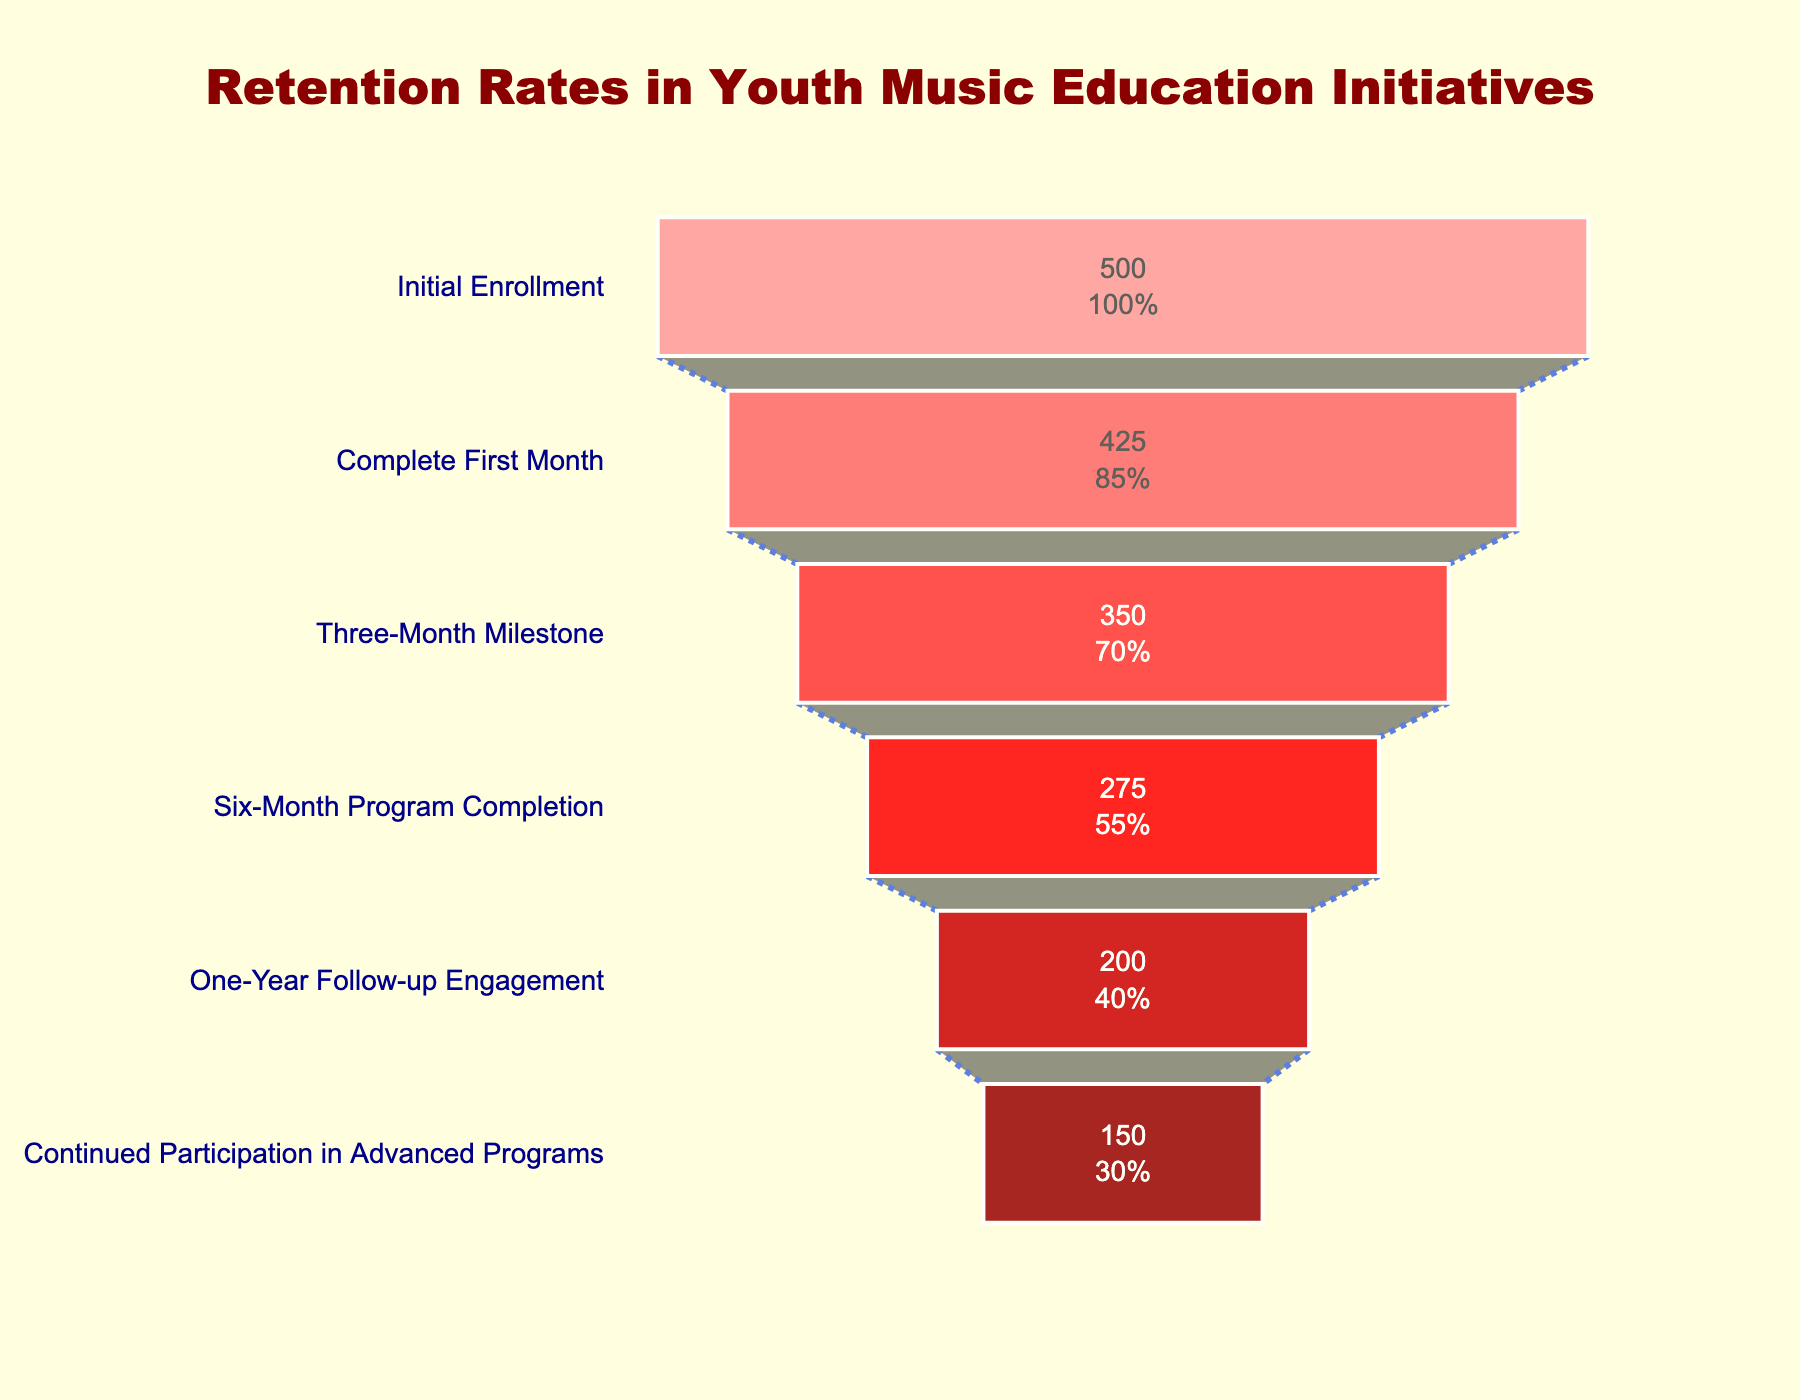How many participants completed the six-month program? The corresponding bar for the "Six-Month Program Completion" stage shows the number of participants as 275.
Answer: 275 What is the title of the funnel chart? The title of the chart is displayed at the top of the figure and reads "Retention Rates in Youth Music Education Initiatives."
Answer: Retention Rates in Youth Music Education Initiatives Which stage has the highest number of participants? The first stage, "Initial Enrollment," has the highest number of participants, shown as 500.
Answer: Initial Enrollment What percentage of participants are still engaged one year after the program? The "One-Year Follow-up Engagement" stage indicates a percentage of 40%, which is directly noted in the figure.
Answer: 40% By how much does the number of participants decrease between the Initial Enrollment and the Three-Month Milestone? The Initial Enrollment stage has 500 participants, and the Three-Month Milestone stage has 350 participants. The difference is 500 - 350 = 150.
Answer: 150 Which stage has the lowest percentage of participants from the initial enrollment? The final stage, "Continued Participation in Advanced Programs," has the lowest percentage at 30%.
Answer: Continued Participation in Advanced Programs What is the approximate percentage drop in participants from the Three-Month Milestone to the Six-Month Program Completion? The percentage at the Three-Month Milestone is 70%, and at the Six-Month Program Completion, it is 55%. Therefore, the approximate percentage drop is 70% - 55% = 15%.
Answer: 15% Comparing the number of participants who complete the first month to those who continue into advanced programs, what is the difference? The number of participants who complete the first month is 425, whereas those who continue into advanced programs are 150. The difference is 425 - 150 = 275.
Answer: 275 What is the color used for the "Six-Month Program Completion" stage bar? According to the figure's color mapping, the bar for the "Six-Month Program Completion" stage is a medium shade of red.
Answer: Medium shade of red Which stage shows a percentage that is exactly half of the initial enrollment? The "Six-Month Program Completion" shows 55%, which is the closest to half of 100%, but not exactly half.
Answer: None 